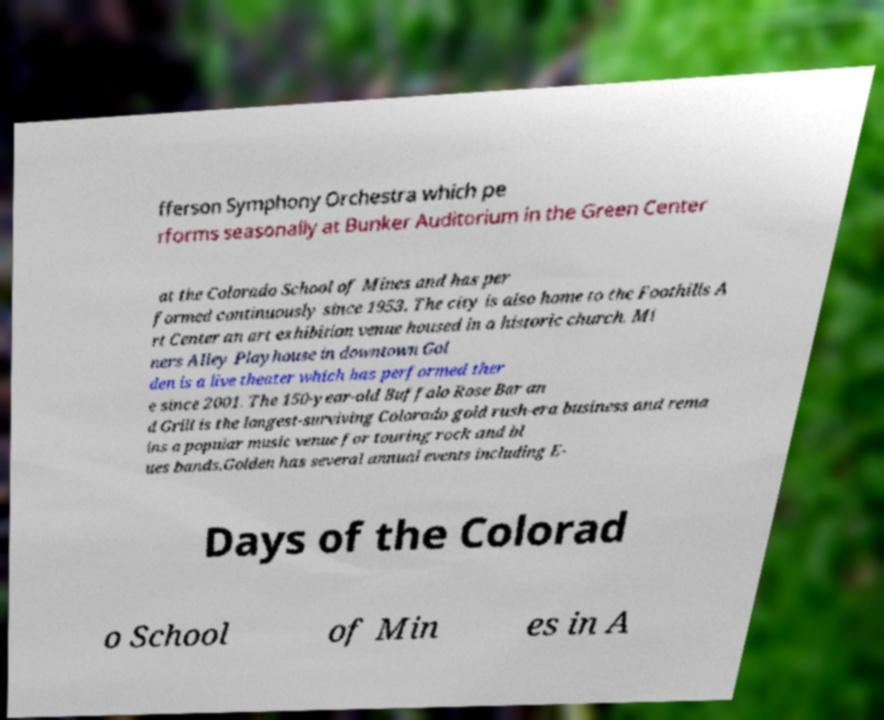What messages or text are displayed in this image? I need them in a readable, typed format. fferson Symphony Orchestra which pe rforms seasonally at Bunker Auditorium in the Green Center at the Colorado School of Mines and has per formed continuously since 1953. The city is also home to the Foothills A rt Center an art exhibition venue housed in a historic church. Mi ners Alley Playhouse in downtown Gol den is a live theater which has performed ther e since 2001. The 150-year-old Buffalo Rose Bar an d Grill is the longest-surviving Colorado gold rush-era business and rema ins a popular music venue for touring rock and bl ues bands.Golden has several annual events including E- Days of the Colorad o School of Min es in A 